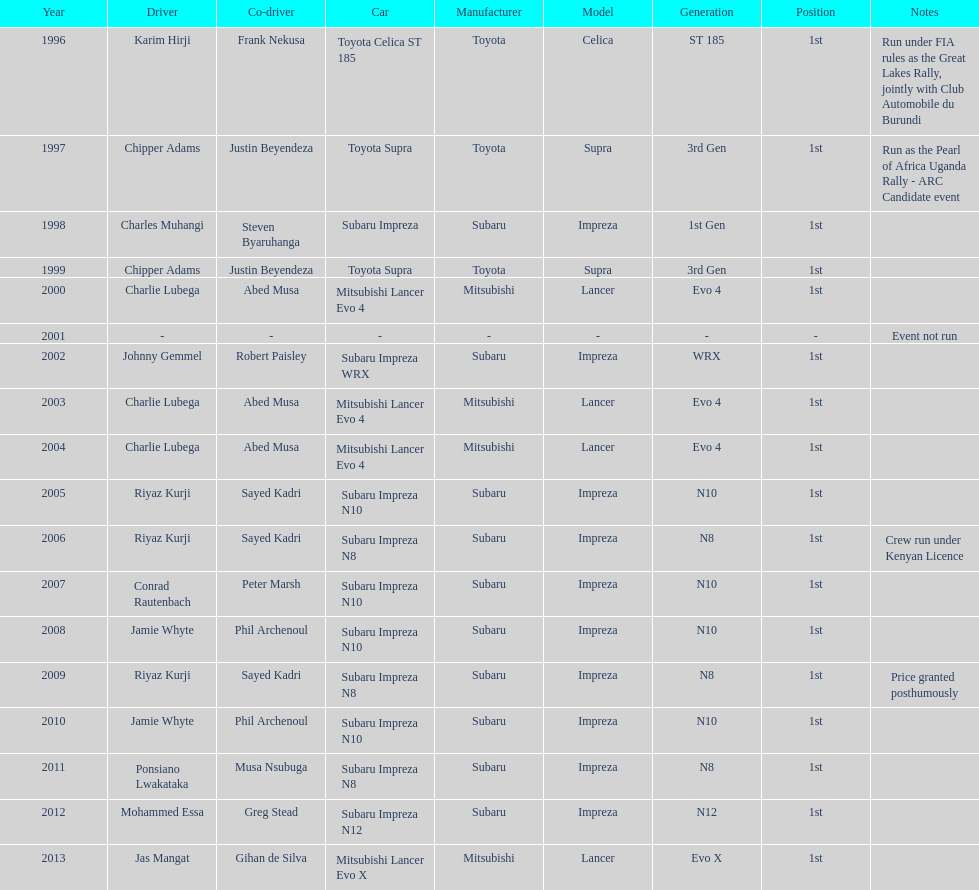Who is the only driver to have consecutive wins? Charlie Lubega. 